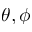<formula> <loc_0><loc_0><loc_500><loc_500>\theta , \phi</formula> 